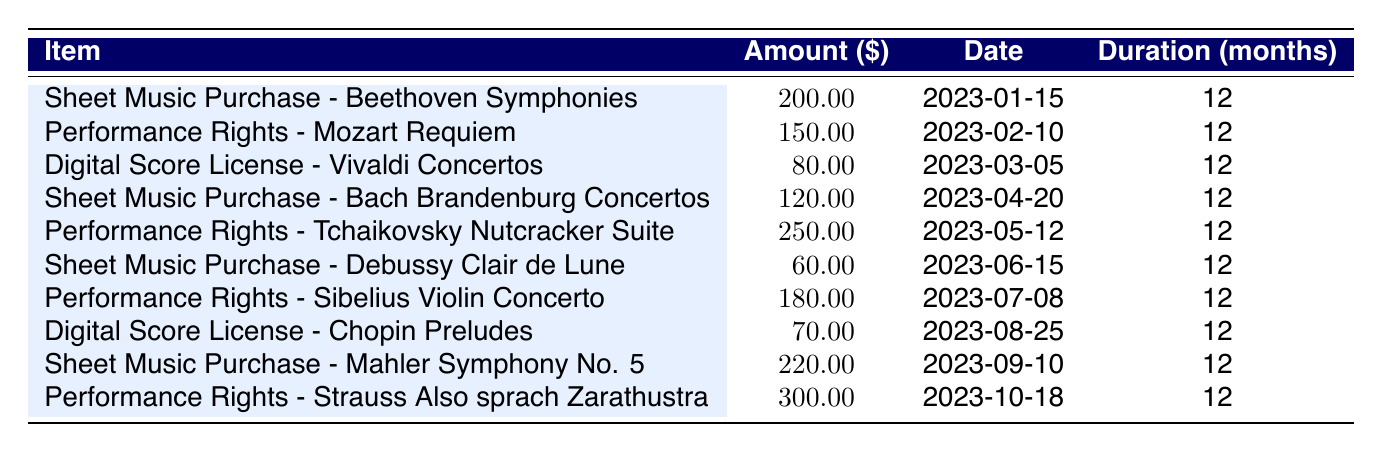What is the total amount spent on sheet music purchases? From the table, the individual amounts for sheet music purchases are: 200.00 (Beethoven), 120.00 (Bach), 60.00 (Debussy), and 220.00 (Mahler). Adding these together: 200.00 + 120.00 + 60.00 + 220.00 = 600.00.
Answer: 600.00 What is the amount for performance rights for the Tchaikovsky Nutcracker Suite? The table lists the performance rights for Tchaikovsky Nutcracker Suite as 250.00.
Answer: 250.00 Is the total amount for digital score licenses greater than 100.00? The table shows amounts for digital score licenses as 80.00 (Vivaldi) and 70.00 (Chopin), which sums to 150.00. Since 150.00 is greater than 100.00, the answer is yes.
Answer: Yes What is the average amount spent on performance rights? The performance rights listed are: 150.00 (Mozart), 250.00 (Tchaikovsky), 180.00 (Sibelius), and 300.00 (Strauss). There are 4 entries, so the total is 150.00 + 250.00 + 180.00 + 300.00 = 880.00. The average is 880.00 divided by 4, which equals 220.00.
Answer: 220.00 Which item has the highest expense, and what is the amount? By checking the table, the performance rights for Strauss Also sprach Zarathustra have the highest amount listed at 300.00.
Answer: Strauss Also sprach Zarathustra: 300.00 What is the total monthly expense if all items are amortized over 12 months? Each expense should be divided by 12 to find the monthly amount. The total expenses are 200.00 + 150.00 + 80.00 + 120.00 + 250.00 + 60.00 + 180.00 + 70.00 + 220.00 + 300.00 = 1510.00. Dividing this by 12 gives approximately 125.83 per month.
Answer: 125.83 Are there more sheet music purchases than performance rights entries in the table? The table lists 4 sheet music purchases and 5 performance rights. Since 4 is less than 5, the answer is no.
Answer: No What was the expense on the earliest purchase in the table? The earliest purchase listed is the sheet music for Beethoven Symphonies dated 2023-01-15, which cost 200.00.
Answer: 200.00 